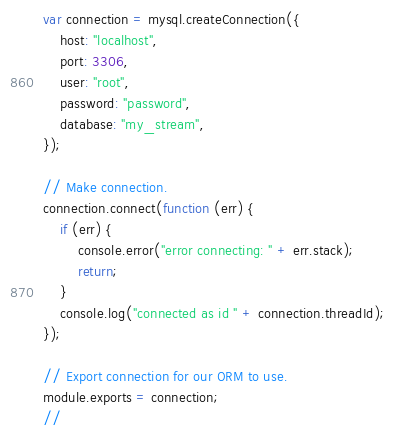<code> <loc_0><loc_0><loc_500><loc_500><_JavaScript_>var connection = mysql.createConnection({
    host: "localhost",
    port: 3306,
    user: "root",
    password: "password",
    database: "my_stream",
});

// Make connection.
connection.connect(function (err) {
    if (err) {
        console.error("error connecting: " + err.stack);
        return;
    }
    console.log("connected as id " + connection.threadId);
});

// Export connection for our ORM to use.
module.exports = connection;
//</code> 